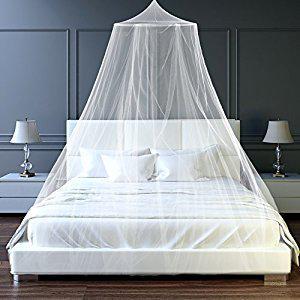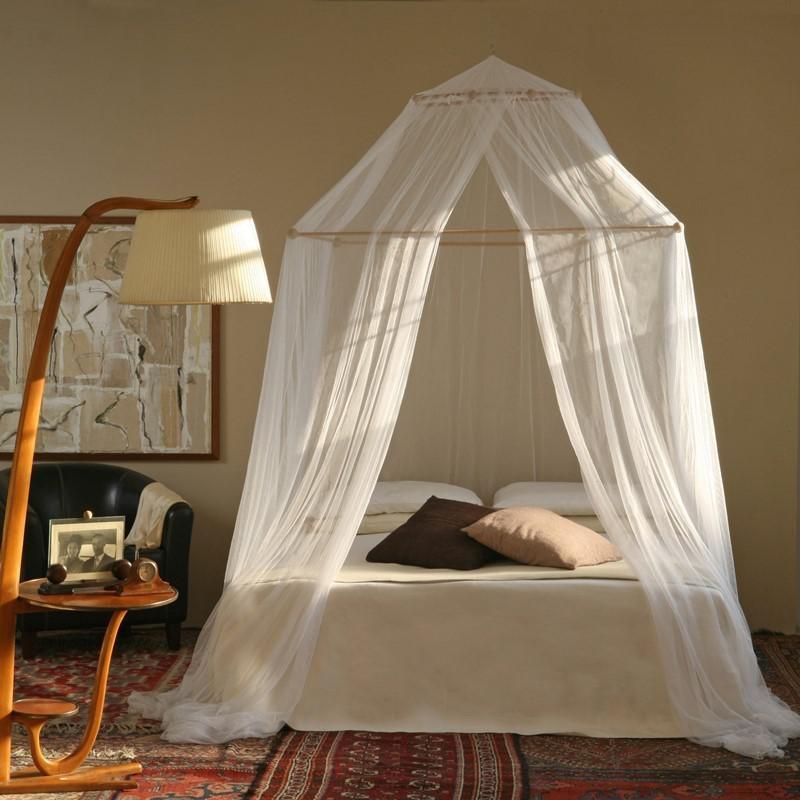The first image is the image on the left, the second image is the image on the right. Considering the images on both sides, is "Beds are draped in a gauzy material that hangs from a central point in the ceiling over each bed." valid? Answer yes or no. Yes. 